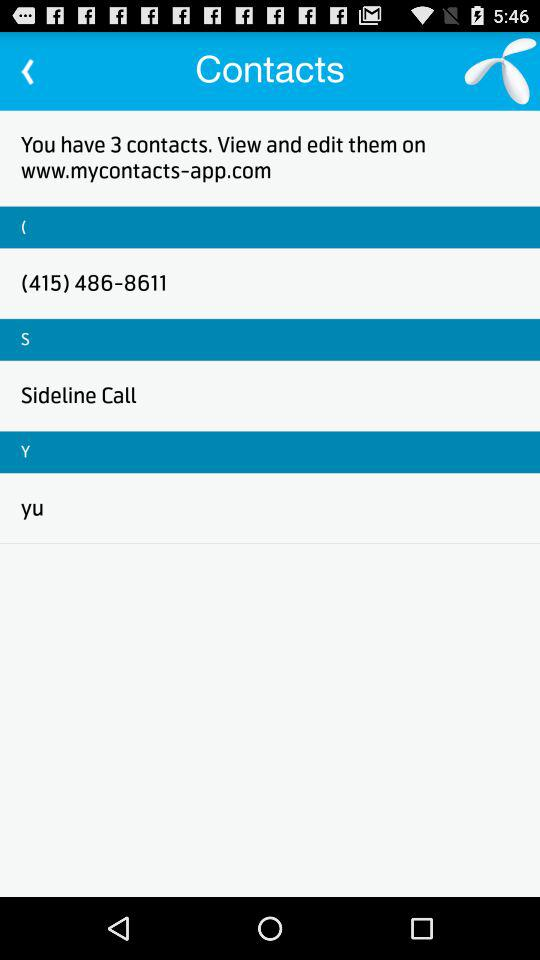How many contacts do you have?
Answer the question using a single word or phrase. 3 